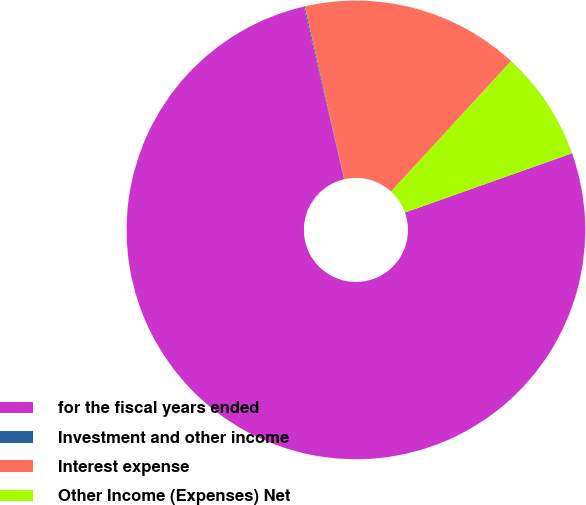Convert chart to OTSL. <chart><loc_0><loc_0><loc_500><loc_500><pie_chart><fcel>for the fiscal years ended<fcel>Investment and other income<fcel>Interest expense<fcel>Other Income (Expenses) Net<nl><fcel>76.78%<fcel>0.07%<fcel>15.41%<fcel>7.74%<nl></chart> 